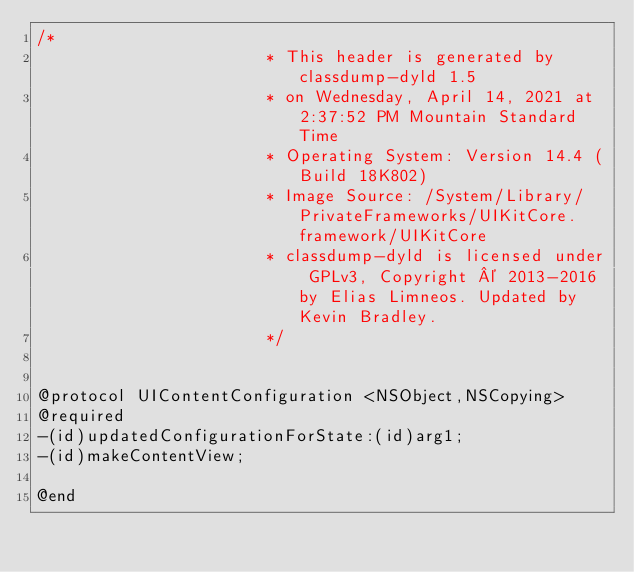<code> <loc_0><loc_0><loc_500><loc_500><_C_>/*
                       * This header is generated by classdump-dyld 1.5
                       * on Wednesday, April 14, 2021 at 2:37:52 PM Mountain Standard Time
                       * Operating System: Version 14.4 (Build 18K802)
                       * Image Source: /System/Library/PrivateFrameworks/UIKitCore.framework/UIKitCore
                       * classdump-dyld is licensed under GPLv3, Copyright © 2013-2016 by Elias Limneos. Updated by Kevin Bradley.
                       */


@protocol UIContentConfiguration <NSObject,NSCopying>
@required
-(id)updatedConfigurationForState:(id)arg1;
-(id)makeContentView;

@end

</code> 